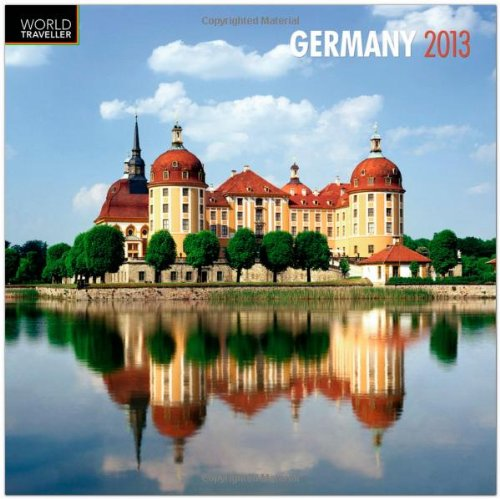What is the title of this book? The calendar is titled 'Germany 2013 Square 12X12 Wall Calendar', and it also specifies that it is a multilingual edition, catering to a diverse group of users. 